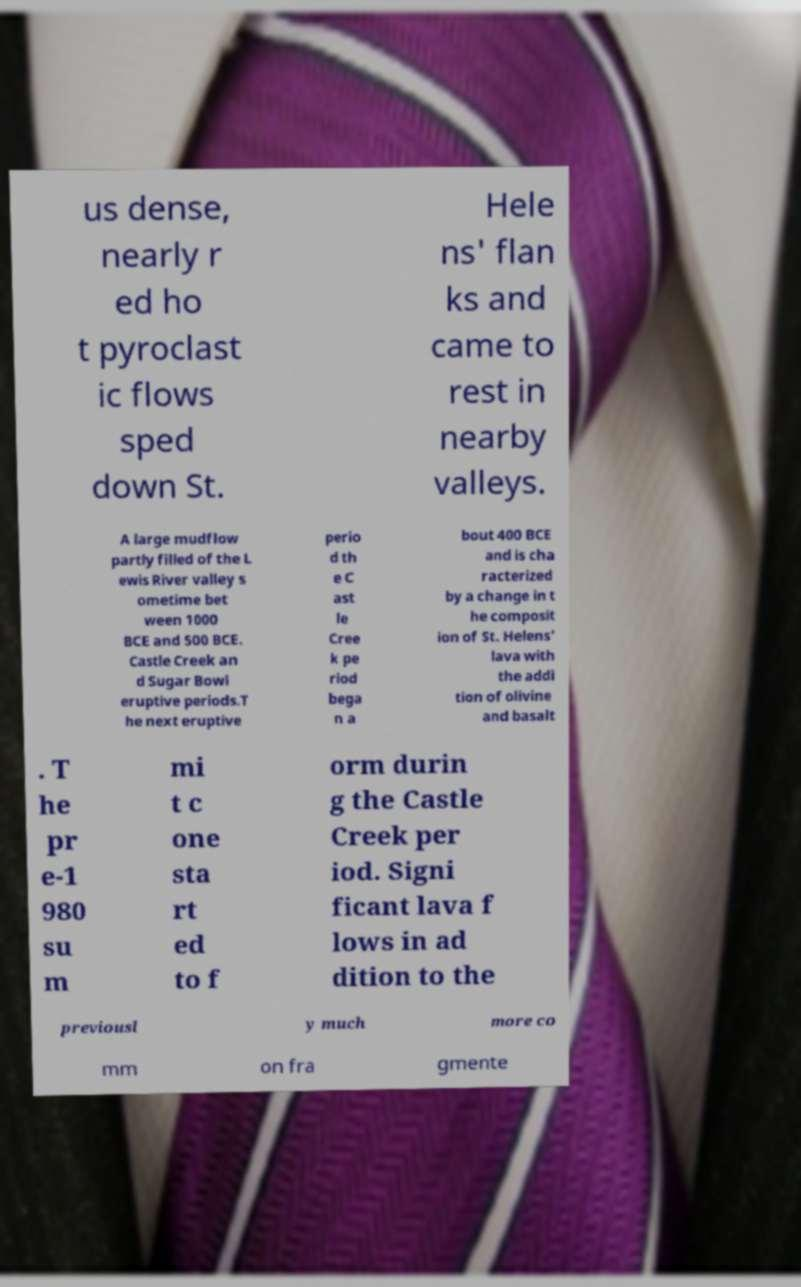What messages or text are displayed in this image? I need them in a readable, typed format. us dense, nearly r ed ho t pyroclast ic flows sped down St. Hele ns' flan ks and came to rest in nearby valleys. A large mudflow partly filled of the L ewis River valley s ometime bet ween 1000 BCE and 500 BCE. Castle Creek an d Sugar Bowl eruptive periods.T he next eruptive perio d th e C ast le Cree k pe riod bega n a bout 400 BCE and is cha racterized by a change in t he composit ion of St. Helens' lava with the addi tion of olivine and basalt . T he pr e-1 980 su m mi t c one sta rt ed to f orm durin g the Castle Creek per iod. Signi ficant lava f lows in ad dition to the previousl y much more co mm on fra gmente 